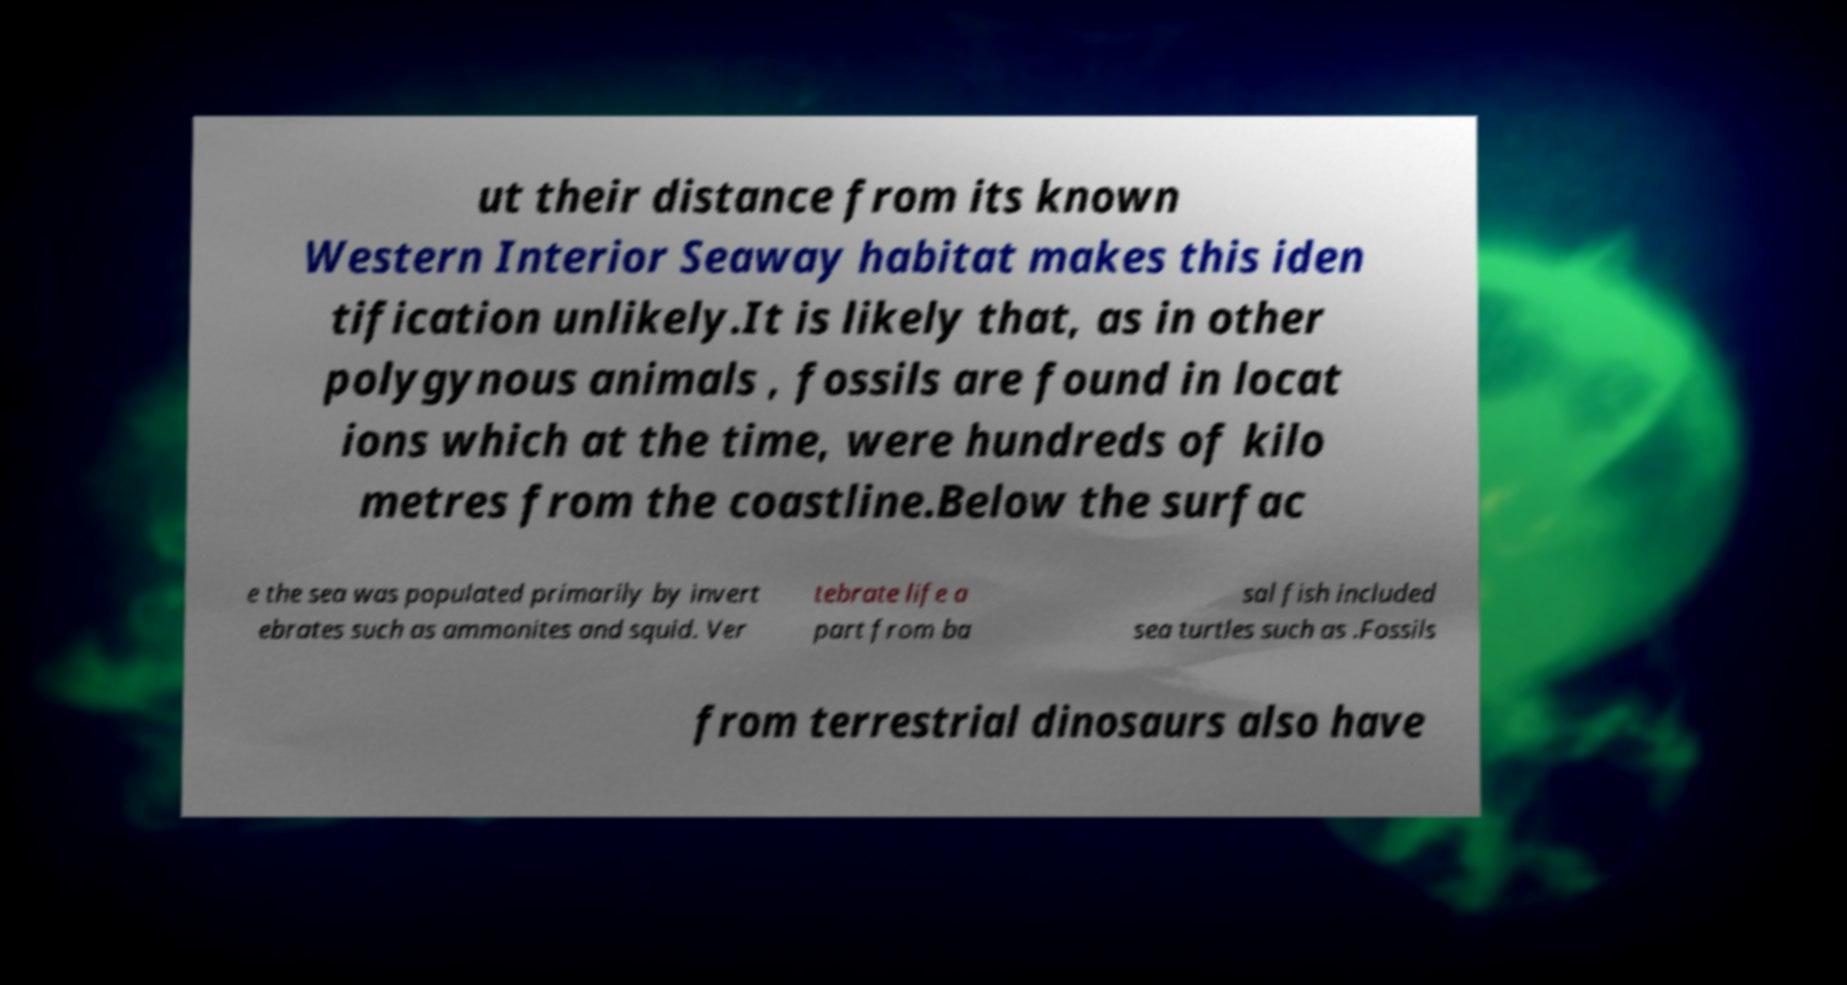Please identify and transcribe the text found in this image. ut their distance from its known Western Interior Seaway habitat makes this iden tification unlikely.It is likely that, as in other polygynous animals , fossils are found in locat ions which at the time, were hundreds of kilo metres from the coastline.Below the surfac e the sea was populated primarily by invert ebrates such as ammonites and squid. Ver tebrate life a part from ba sal fish included sea turtles such as .Fossils from terrestrial dinosaurs also have 